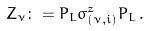<formula> <loc_0><loc_0><loc_500><loc_500>Z _ { \nu } \colon = P _ { L } \sigma ^ { z } _ { ( \nu , i ) } P _ { L } \, .</formula> 